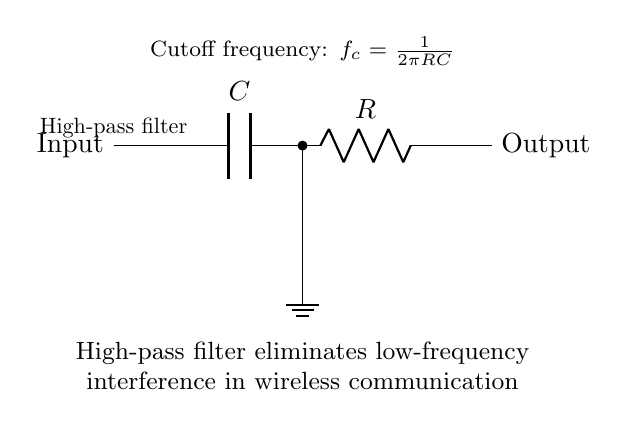What type of filter is represented in this circuit? The circuit has a capacitor and a resistor in series, indicating it is a high-pass filter designed to allow high-frequency signals to pass while blocking low-frequency signals.
Answer: High-pass filter What component is located directly after the input? The first component in the circuit after the input is a capacitor, which plays a key role in the functioning of the high-pass filter.
Answer: Capacitor What is the cutoff frequency formula displayed in the circuit? The circuit includes the formula for cutoff frequency, which is essential for understanding the frequency response of the filter. The formula is derived from the relationship between resistance and capacitance: f_c = 1/(2πRC).
Answer: f_c = 1/(2πRC) How many components are connected in series in this circuit? The circuit features two main components (capacitor and resistor) connected in series, indicating that the current flows through each component in turn.
Answer: Two What happens to low-frequency signals in this filter? The design of the high-pass filter specifies that low-frequency signals are eliminated, allowing only higher-frequency signals to move forward in the circuit.
Answer: Eliminated What is connected to the output of this circuit? At the output terminal, there is no additional component shown, which means the output directly takes the filtered signal that passed through the capacitor and resistor.
Answer: Output 